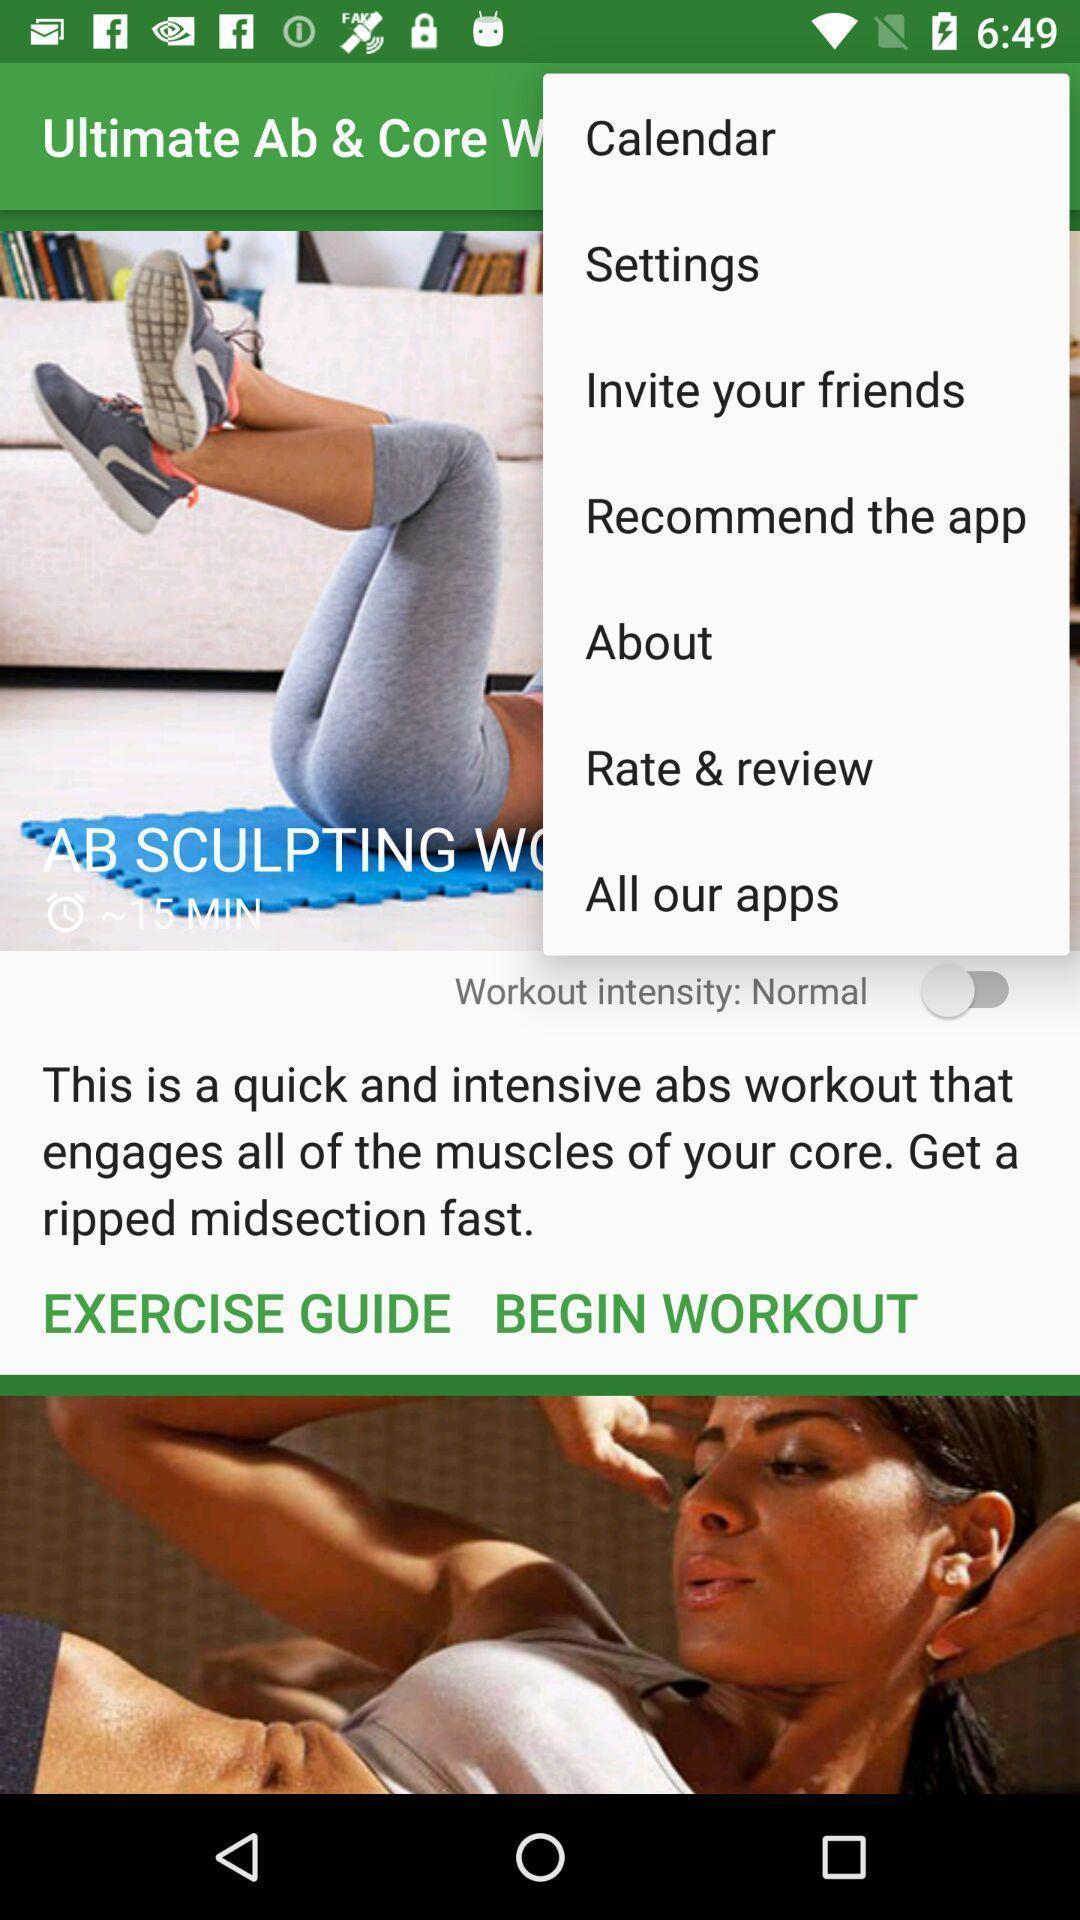Describe this image in words. Screen shows multiple options in a fitness application. 